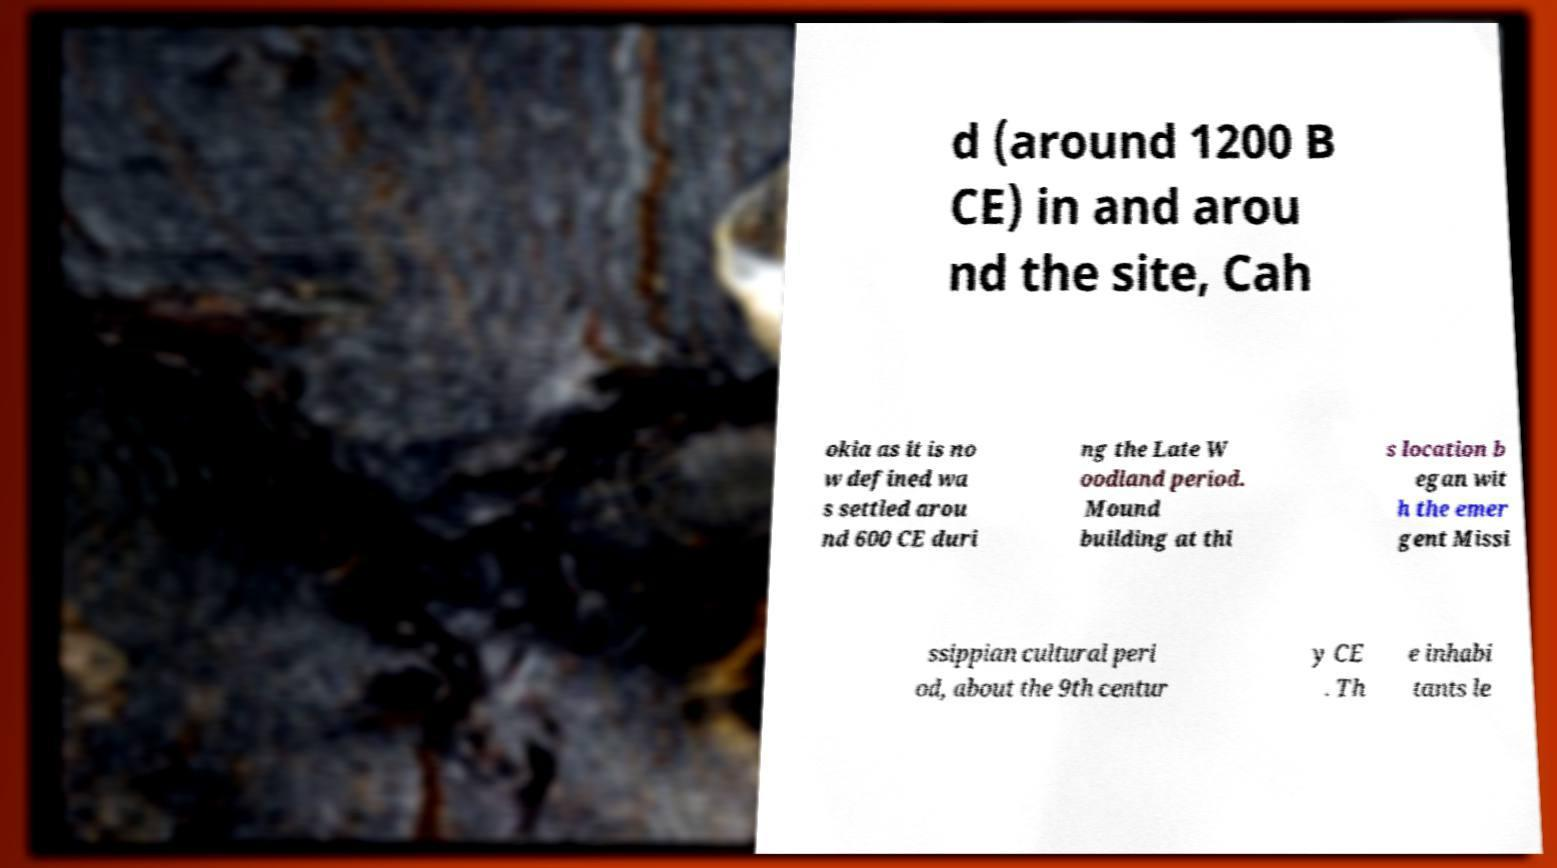Could you extract and type out the text from this image? d (around 1200 B CE) in and arou nd the site, Cah okia as it is no w defined wa s settled arou nd 600 CE duri ng the Late W oodland period. Mound building at thi s location b egan wit h the emer gent Missi ssippian cultural peri od, about the 9th centur y CE . Th e inhabi tants le 